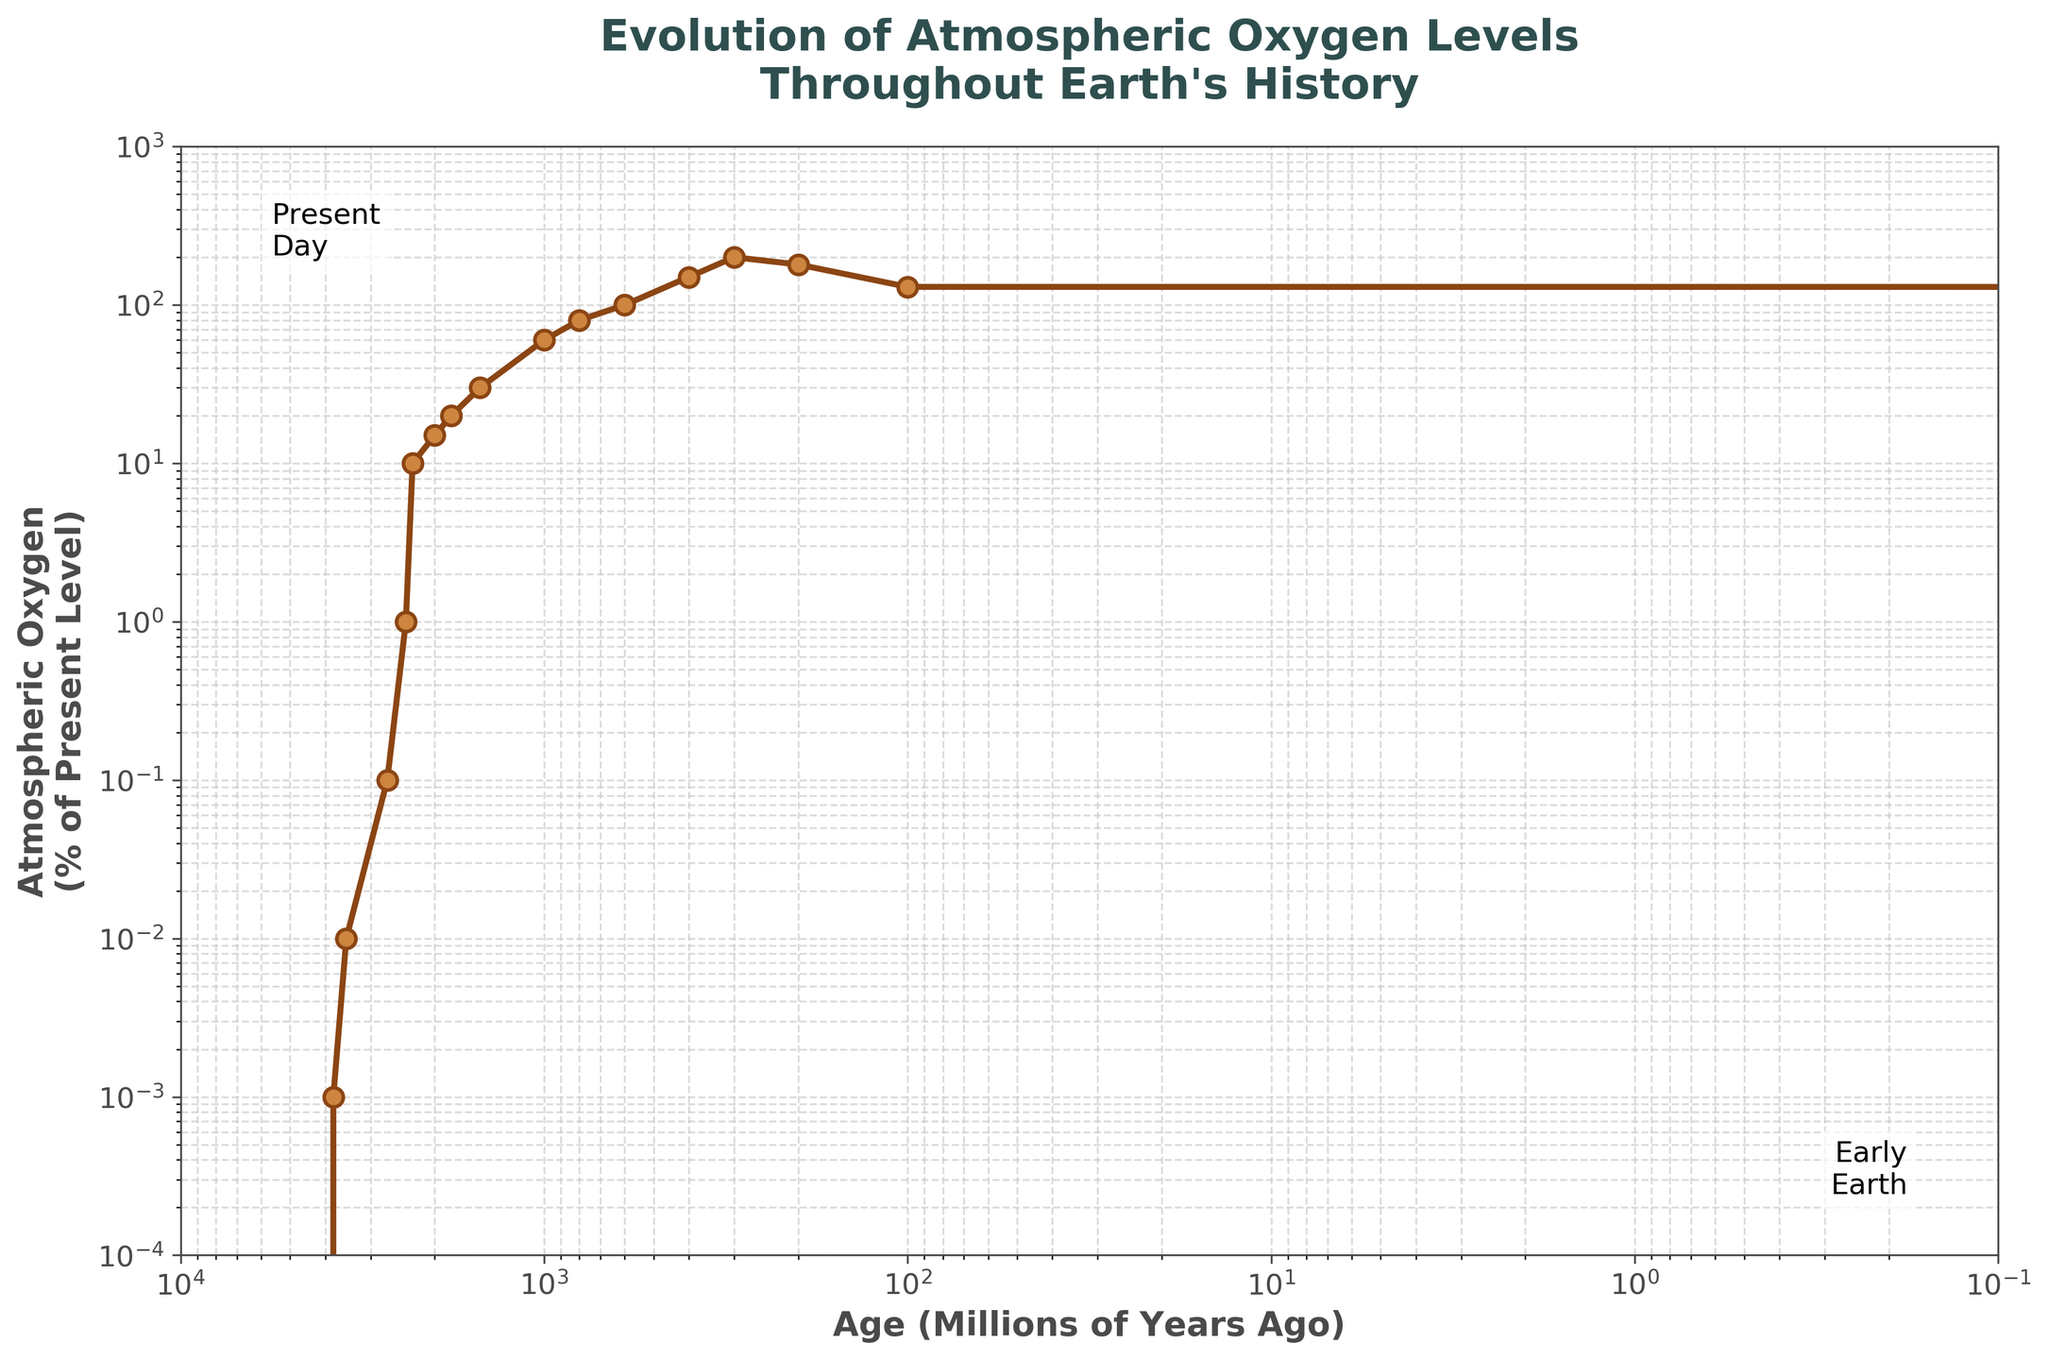What is the atmospheric oxygen level in percentage of the present level around 2300 million years ago? The plotted line shows data points at various ages. At 2300 million years ago, the y-value indicates the atmospheric oxygen level.
Answer: 10% How does the atmospheric oxygen level change from 600 million years ago to the present day? The figure shows that the oxygen level at 600 million years ago is 100% and at present day it is also 100%, indicating no change in the percentage relative to present level during this period.
Answer: No change What is the maximum atmospheric oxygen level recorded in the figure, and around what age was it? Observing the y-axis and data points, the maximum oxygen level occurs around 300 million years ago, where it reaches 200% of the present level.
Answer: 200%, 300 million years ago By how much did the atmospheric oxygen level increase between 2400 million years ago and 2000 million years ago? At 2400 million years ago, the oxygen level is 1% of the present level, and at 2000 million years ago, it is 15%. The increase is 15% - 1% = 14%.
Answer: 14% At which point in Earth's history did the atmospheric oxygen level first notably increase from near zero values? The first notable increase is observed around 2700 million years ago, where the level jumps to 0.1% from near zero values.
Answer: 2700 million years ago Compare the atmospheric oxygen levels at 1000 million years ago and 100 million years ago. Which period had higher oxygen levels? From the plot, the oxygen level is 60% at 1000 million years ago and 130% at 100 million years ago. 100 million years ago had a higher oxygen level.
Answer: 100 million years ago Calculate the percentage increase in atmospheric oxygen from 1000 million years ago to 400 million years ago. The oxygen level at 1000 million years ago was 60%, and at 400 million years ago, it’s 150%. The percentage increase is ((150 - 60) / 60) * 100 = 150%.
Answer: 150% What was the atmospheric oxygen level at 0 million years ago (present day) compared to 800 million years ago? Present day oxygen level is at 100%, while it is 80% at 800 million years ago.
Answer: Present day is higher During which period did the atmospheric oxygen level experience the most significant increase? The most significant increase happens between 2400 to 2300 million years ago, where it jumps from 1% to 10%.
Answer: 2400 to 2300 million years ago What trend can be observed in the atmospheric oxygen level from 300 million years ago to the present day? From 300 million years ago (200%) to present day (100%), the plot shows a decreasing trend in the atmospheric oxygen level.
Answer: Decreasing trend 